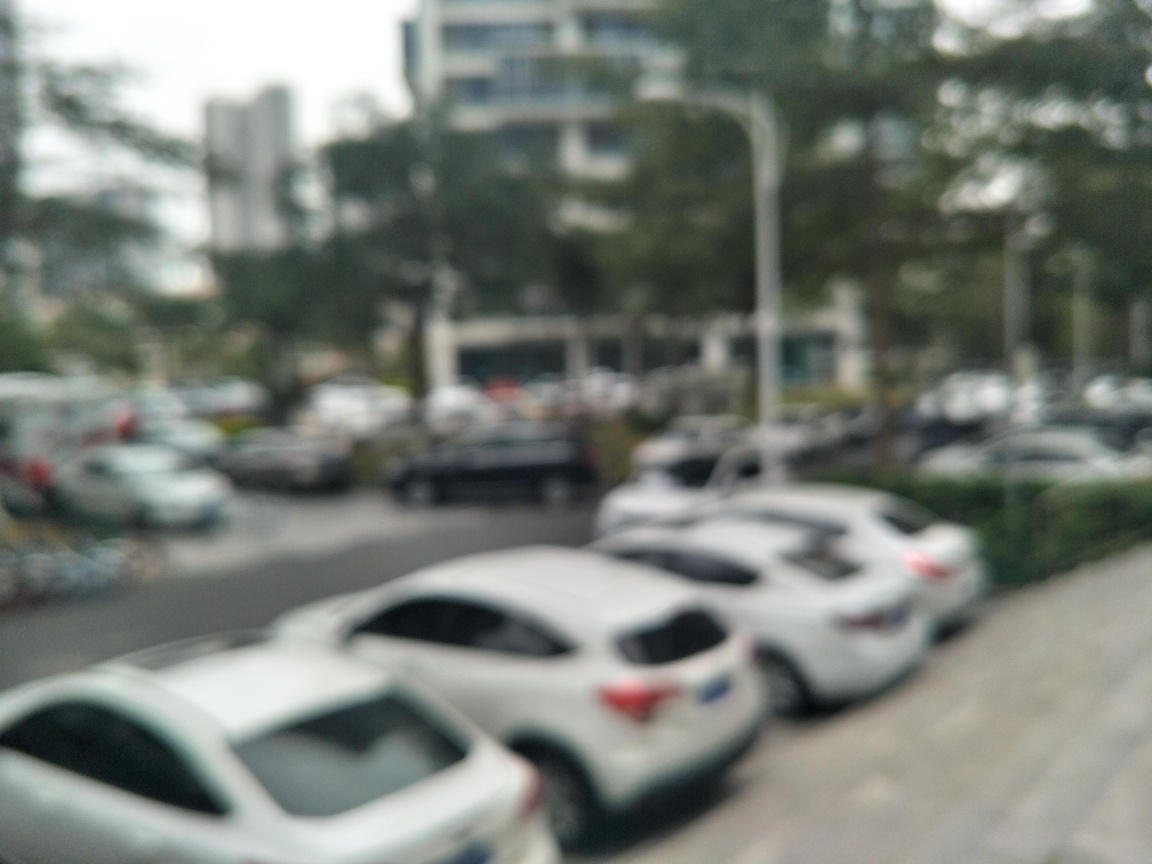Is there anything in the image that suggests the location where it was taken? It's challenging to determine the exact location from this out-of-focus image. However, the presence of multiple cars parked along the side of the road might indicate an urban area, possibly in a busy commercial or business district. The styles of the vehicles and the glimpse of buildings in the background also suggest it's a city environment. 